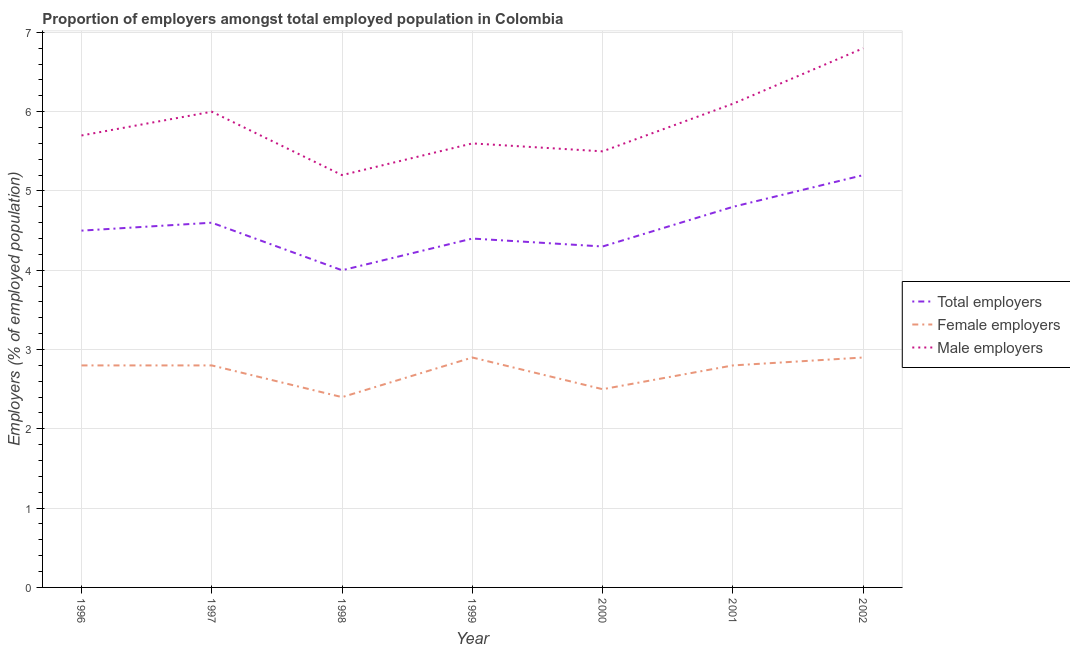Does the line corresponding to percentage of male employers intersect with the line corresponding to percentage of female employers?
Offer a terse response. No. What is the percentage of total employers in 1997?
Keep it short and to the point. 4.6. Across all years, what is the maximum percentage of total employers?
Keep it short and to the point. 5.2. In which year was the percentage of total employers minimum?
Keep it short and to the point. 1998. What is the total percentage of total employers in the graph?
Your answer should be very brief. 31.8. What is the difference between the percentage of total employers in 2000 and that in 2001?
Your response must be concise. -0.5. What is the difference between the percentage of female employers in 2001 and the percentage of male employers in 1996?
Your answer should be compact. -2.9. What is the average percentage of male employers per year?
Your response must be concise. 5.84. In the year 1997, what is the difference between the percentage of male employers and percentage of female employers?
Provide a succinct answer. 3.2. What is the ratio of the percentage of total employers in 1998 to that in 2001?
Ensure brevity in your answer.  0.83. Is the percentage of total employers in 1997 less than that in 2002?
Provide a short and direct response. Yes. What is the difference between the highest and the second highest percentage of female employers?
Offer a very short reply. 0. What is the difference between the highest and the lowest percentage of male employers?
Offer a very short reply. 1.6. In how many years, is the percentage of female employers greater than the average percentage of female employers taken over all years?
Make the answer very short. 5. Is the percentage of female employers strictly greater than the percentage of male employers over the years?
Provide a succinct answer. No. Is the percentage of male employers strictly less than the percentage of female employers over the years?
Your answer should be compact. No. How many years are there in the graph?
Offer a terse response. 7. Are the values on the major ticks of Y-axis written in scientific E-notation?
Give a very brief answer. No. Where does the legend appear in the graph?
Your response must be concise. Center right. How are the legend labels stacked?
Provide a short and direct response. Vertical. What is the title of the graph?
Keep it short and to the point. Proportion of employers amongst total employed population in Colombia. Does "Natural gas sources" appear as one of the legend labels in the graph?
Provide a succinct answer. No. What is the label or title of the X-axis?
Make the answer very short. Year. What is the label or title of the Y-axis?
Offer a very short reply. Employers (% of employed population). What is the Employers (% of employed population) of Female employers in 1996?
Offer a very short reply. 2.8. What is the Employers (% of employed population) of Male employers in 1996?
Your answer should be very brief. 5.7. What is the Employers (% of employed population) in Total employers in 1997?
Make the answer very short. 4.6. What is the Employers (% of employed population) in Female employers in 1997?
Provide a short and direct response. 2.8. What is the Employers (% of employed population) of Male employers in 1997?
Give a very brief answer. 6. What is the Employers (% of employed population) of Total employers in 1998?
Your answer should be compact. 4. What is the Employers (% of employed population) of Female employers in 1998?
Your response must be concise. 2.4. What is the Employers (% of employed population) of Male employers in 1998?
Provide a succinct answer. 5.2. What is the Employers (% of employed population) in Total employers in 1999?
Your response must be concise. 4.4. What is the Employers (% of employed population) of Female employers in 1999?
Offer a very short reply. 2.9. What is the Employers (% of employed population) of Male employers in 1999?
Give a very brief answer. 5.6. What is the Employers (% of employed population) in Total employers in 2000?
Provide a succinct answer. 4.3. What is the Employers (% of employed population) in Male employers in 2000?
Provide a succinct answer. 5.5. What is the Employers (% of employed population) of Total employers in 2001?
Provide a succinct answer. 4.8. What is the Employers (% of employed population) of Female employers in 2001?
Make the answer very short. 2.8. What is the Employers (% of employed population) of Male employers in 2001?
Give a very brief answer. 6.1. What is the Employers (% of employed population) in Total employers in 2002?
Provide a succinct answer. 5.2. What is the Employers (% of employed population) in Female employers in 2002?
Your answer should be compact. 2.9. What is the Employers (% of employed population) in Male employers in 2002?
Your answer should be compact. 6.8. Across all years, what is the maximum Employers (% of employed population) in Total employers?
Your answer should be very brief. 5.2. Across all years, what is the maximum Employers (% of employed population) of Female employers?
Keep it short and to the point. 2.9. Across all years, what is the maximum Employers (% of employed population) of Male employers?
Your answer should be very brief. 6.8. Across all years, what is the minimum Employers (% of employed population) of Total employers?
Offer a terse response. 4. Across all years, what is the minimum Employers (% of employed population) in Female employers?
Your response must be concise. 2.4. Across all years, what is the minimum Employers (% of employed population) of Male employers?
Your response must be concise. 5.2. What is the total Employers (% of employed population) in Total employers in the graph?
Offer a terse response. 31.8. What is the total Employers (% of employed population) in Male employers in the graph?
Give a very brief answer. 40.9. What is the difference between the Employers (% of employed population) of Male employers in 1996 and that in 1997?
Keep it short and to the point. -0.3. What is the difference between the Employers (% of employed population) of Female employers in 1996 and that in 1998?
Your response must be concise. 0.4. What is the difference between the Employers (% of employed population) of Male employers in 1996 and that in 1998?
Your answer should be very brief. 0.5. What is the difference between the Employers (% of employed population) in Total employers in 1996 and that in 1999?
Ensure brevity in your answer.  0.1. What is the difference between the Employers (% of employed population) in Male employers in 1996 and that in 1999?
Provide a short and direct response. 0.1. What is the difference between the Employers (% of employed population) of Female employers in 1996 and that in 2001?
Your answer should be very brief. 0. What is the difference between the Employers (% of employed population) in Male employers in 1996 and that in 2002?
Give a very brief answer. -1.1. What is the difference between the Employers (% of employed population) of Total employers in 1997 and that in 1998?
Your answer should be very brief. 0.6. What is the difference between the Employers (% of employed population) of Female employers in 1997 and that in 1998?
Keep it short and to the point. 0.4. What is the difference between the Employers (% of employed population) of Male employers in 1997 and that in 1998?
Your answer should be very brief. 0.8. What is the difference between the Employers (% of employed population) of Total employers in 1997 and that in 2000?
Give a very brief answer. 0.3. What is the difference between the Employers (% of employed population) in Female employers in 1997 and that in 2000?
Give a very brief answer. 0.3. What is the difference between the Employers (% of employed population) of Male employers in 1997 and that in 2000?
Your answer should be compact. 0.5. What is the difference between the Employers (% of employed population) of Female employers in 1998 and that in 1999?
Give a very brief answer. -0.5. What is the difference between the Employers (% of employed population) of Male employers in 1998 and that in 2000?
Provide a short and direct response. -0.3. What is the difference between the Employers (% of employed population) in Male employers in 1998 and that in 2001?
Your answer should be compact. -0.9. What is the difference between the Employers (% of employed population) of Total employers in 1998 and that in 2002?
Provide a short and direct response. -1.2. What is the difference between the Employers (% of employed population) in Male employers in 1999 and that in 2000?
Keep it short and to the point. 0.1. What is the difference between the Employers (% of employed population) of Female employers in 1999 and that in 2001?
Offer a very short reply. 0.1. What is the difference between the Employers (% of employed population) of Total employers in 2000 and that in 2002?
Offer a very short reply. -0.9. What is the difference between the Employers (% of employed population) in Female employers in 2000 and that in 2002?
Keep it short and to the point. -0.4. What is the difference between the Employers (% of employed population) in Total employers in 1996 and the Employers (% of employed population) in Female employers in 1997?
Provide a short and direct response. 1.7. What is the difference between the Employers (% of employed population) in Female employers in 1996 and the Employers (% of employed population) in Male employers in 1997?
Provide a succinct answer. -3.2. What is the difference between the Employers (% of employed population) of Total employers in 1996 and the Employers (% of employed population) of Female employers in 1998?
Your answer should be compact. 2.1. What is the difference between the Employers (% of employed population) of Total employers in 1996 and the Employers (% of employed population) of Female employers in 1999?
Give a very brief answer. 1.6. What is the difference between the Employers (% of employed population) in Total employers in 1996 and the Employers (% of employed population) in Female employers in 2000?
Provide a short and direct response. 2. What is the difference between the Employers (% of employed population) of Female employers in 1996 and the Employers (% of employed population) of Male employers in 2000?
Offer a terse response. -2.7. What is the difference between the Employers (% of employed population) in Total employers in 1996 and the Employers (% of employed population) in Male employers in 2001?
Provide a short and direct response. -1.6. What is the difference between the Employers (% of employed population) in Total employers in 1997 and the Employers (% of employed population) in Female employers in 1998?
Provide a succinct answer. 2.2. What is the difference between the Employers (% of employed population) in Total employers in 1997 and the Employers (% of employed population) in Male employers in 1998?
Keep it short and to the point. -0.6. What is the difference between the Employers (% of employed population) of Female employers in 1997 and the Employers (% of employed population) of Male employers in 1998?
Your answer should be very brief. -2.4. What is the difference between the Employers (% of employed population) of Total employers in 1997 and the Employers (% of employed population) of Female employers in 1999?
Keep it short and to the point. 1.7. What is the difference between the Employers (% of employed population) in Female employers in 1997 and the Employers (% of employed population) in Male employers in 2000?
Offer a very short reply. -2.7. What is the difference between the Employers (% of employed population) of Total employers in 1997 and the Employers (% of employed population) of Female employers in 2002?
Make the answer very short. 1.7. What is the difference between the Employers (% of employed population) in Female employers in 1997 and the Employers (% of employed population) in Male employers in 2002?
Give a very brief answer. -4. What is the difference between the Employers (% of employed population) in Total employers in 1998 and the Employers (% of employed population) in Female employers in 2000?
Provide a short and direct response. 1.5. What is the difference between the Employers (% of employed population) of Total employers in 1998 and the Employers (% of employed population) of Male employers in 2000?
Provide a short and direct response. -1.5. What is the difference between the Employers (% of employed population) of Female employers in 1998 and the Employers (% of employed population) of Male employers in 2000?
Offer a very short reply. -3.1. What is the difference between the Employers (% of employed population) of Total employers in 1998 and the Employers (% of employed population) of Female employers in 2001?
Offer a very short reply. 1.2. What is the difference between the Employers (% of employed population) of Total employers in 1998 and the Employers (% of employed population) of Male employers in 2001?
Offer a terse response. -2.1. What is the difference between the Employers (% of employed population) of Female employers in 1998 and the Employers (% of employed population) of Male employers in 2001?
Provide a short and direct response. -3.7. What is the difference between the Employers (% of employed population) of Total employers in 1998 and the Employers (% of employed population) of Female employers in 2002?
Make the answer very short. 1.1. What is the difference between the Employers (% of employed population) in Total employers in 1998 and the Employers (% of employed population) in Male employers in 2002?
Offer a terse response. -2.8. What is the difference between the Employers (% of employed population) in Female employers in 1998 and the Employers (% of employed population) in Male employers in 2002?
Provide a succinct answer. -4.4. What is the difference between the Employers (% of employed population) in Total employers in 1999 and the Employers (% of employed population) in Male employers in 2000?
Your answer should be compact. -1.1. What is the difference between the Employers (% of employed population) of Female employers in 1999 and the Employers (% of employed population) of Male employers in 2000?
Your response must be concise. -2.6. What is the difference between the Employers (% of employed population) of Total employers in 1999 and the Employers (% of employed population) of Male employers in 2001?
Ensure brevity in your answer.  -1.7. What is the difference between the Employers (% of employed population) in Total employers in 1999 and the Employers (% of employed population) in Female employers in 2002?
Your answer should be very brief. 1.5. What is the difference between the Employers (% of employed population) in Total employers in 1999 and the Employers (% of employed population) in Male employers in 2002?
Give a very brief answer. -2.4. What is the difference between the Employers (% of employed population) in Total employers in 2000 and the Employers (% of employed population) in Female employers in 2001?
Your answer should be compact. 1.5. What is the difference between the Employers (% of employed population) of Total employers in 2000 and the Employers (% of employed population) of Male employers in 2001?
Your answer should be very brief. -1.8. What is the difference between the Employers (% of employed population) in Total employers in 2000 and the Employers (% of employed population) in Female employers in 2002?
Your answer should be compact. 1.4. What is the difference between the Employers (% of employed population) in Female employers in 2000 and the Employers (% of employed population) in Male employers in 2002?
Give a very brief answer. -4.3. What is the difference between the Employers (% of employed population) in Female employers in 2001 and the Employers (% of employed population) in Male employers in 2002?
Make the answer very short. -4. What is the average Employers (% of employed population) of Total employers per year?
Make the answer very short. 4.54. What is the average Employers (% of employed population) of Female employers per year?
Offer a terse response. 2.73. What is the average Employers (% of employed population) of Male employers per year?
Your response must be concise. 5.84. In the year 1996, what is the difference between the Employers (% of employed population) in Total employers and Employers (% of employed population) in Female employers?
Ensure brevity in your answer.  1.7. In the year 1996, what is the difference between the Employers (% of employed population) in Total employers and Employers (% of employed population) in Male employers?
Your response must be concise. -1.2. In the year 1997, what is the difference between the Employers (% of employed population) of Total employers and Employers (% of employed population) of Female employers?
Your answer should be very brief. 1.8. In the year 1998, what is the difference between the Employers (% of employed population) of Total employers and Employers (% of employed population) of Male employers?
Offer a very short reply. -1.2. In the year 1998, what is the difference between the Employers (% of employed population) in Female employers and Employers (% of employed population) in Male employers?
Your response must be concise. -2.8. In the year 2000, what is the difference between the Employers (% of employed population) of Total employers and Employers (% of employed population) of Female employers?
Keep it short and to the point. 1.8. In the year 2000, what is the difference between the Employers (% of employed population) in Total employers and Employers (% of employed population) in Male employers?
Make the answer very short. -1.2. In the year 2001, what is the difference between the Employers (% of employed population) in Total employers and Employers (% of employed population) in Male employers?
Ensure brevity in your answer.  -1.3. In the year 2001, what is the difference between the Employers (% of employed population) of Female employers and Employers (% of employed population) of Male employers?
Your response must be concise. -3.3. In the year 2002, what is the difference between the Employers (% of employed population) of Total employers and Employers (% of employed population) of Female employers?
Provide a succinct answer. 2.3. In the year 2002, what is the difference between the Employers (% of employed population) in Total employers and Employers (% of employed population) in Male employers?
Provide a succinct answer. -1.6. In the year 2002, what is the difference between the Employers (% of employed population) of Female employers and Employers (% of employed population) of Male employers?
Offer a very short reply. -3.9. What is the ratio of the Employers (% of employed population) in Total employers in 1996 to that in 1997?
Offer a very short reply. 0.98. What is the ratio of the Employers (% of employed population) of Female employers in 1996 to that in 1997?
Make the answer very short. 1. What is the ratio of the Employers (% of employed population) of Total employers in 1996 to that in 1998?
Your response must be concise. 1.12. What is the ratio of the Employers (% of employed population) in Female employers in 1996 to that in 1998?
Your answer should be compact. 1.17. What is the ratio of the Employers (% of employed population) of Male employers in 1996 to that in 1998?
Give a very brief answer. 1.1. What is the ratio of the Employers (% of employed population) in Total employers in 1996 to that in 1999?
Offer a very short reply. 1.02. What is the ratio of the Employers (% of employed population) in Female employers in 1996 to that in 1999?
Your answer should be very brief. 0.97. What is the ratio of the Employers (% of employed population) of Male employers in 1996 to that in 1999?
Make the answer very short. 1.02. What is the ratio of the Employers (% of employed population) in Total employers in 1996 to that in 2000?
Your response must be concise. 1.05. What is the ratio of the Employers (% of employed population) of Female employers in 1996 to that in 2000?
Ensure brevity in your answer.  1.12. What is the ratio of the Employers (% of employed population) of Male employers in 1996 to that in 2000?
Your response must be concise. 1.04. What is the ratio of the Employers (% of employed population) of Male employers in 1996 to that in 2001?
Your answer should be very brief. 0.93. What is the ratio of the Employers (% of employed population) of Total employers in 1996 to that in 2002?
Your answer should be very brief. 0.87. What is the ratio of the Employers (% of employed population) in Female employers in 1996 to that in 2002?
Your answer should be very brief. 0.97. What is the ratio of the Employers (% of employed population) in Male employers in 1996 to that in 2002?
Your answer should be very brief. 0.84. What is the ratio of the Employers (% of employed population) of Total employers in 1997 to that in 1998?
Provide a short and direct response. 1.15. What is the ratio of the Employers (% of employed population) in Male employers in 1997 to that in 1998?
Your response must be concise. 1.15. What is the ratio of the Employers (% of employed population) of Total employers in 1997 to that in 1999?
Provide a succinct answer. 1.05. What is the ratio of the Employers (% of employed population) in Female employers in 1997 to that in 1999?
Ensure brevity in your answer.  0.97. What is the ratio of the Employers (% of employed population) in Male employers in 1997 to that in 1999?
Give a very brief answer. 1.07. What is the ratio of the Employers (% of employed population) in Total employers in 1997 to that in 2000?
Give a very brief answer. 1.07. What is the ratio of the Employers (% of employed population) of Female employers in 1997 to that in 2000?
Your answer should be compact. 1.12. What is the ratio of the Employers (% of employed population) of Female employers in 1997 to that in 2001?
Give a very brief answer. 1. What is the ratio of the Employers (% of employed population) of Male employers in 1997 to that in 2001?
Keep it short and to the point. 0.98. What is the ratio of the Employers (% of employed population) of Total employers in 1997 to that in 2002?
Ensure brevity in your answer.  0.88. What is the ratio of the Employers (% of employed population) of Female employers in 1997 to that in 2002?
Your answer should be compact. 0.97. What is the ratio of the Employers (% of employed population) of Male employers in 1997 to that in 2002?
Offer a terse response. 0.88. What is the ratio of the Employers (% of employed population) in Female employers in 1998 to that in 1999?
Provide a short and direct response. 0.83. What is the ratio of the Employers (% of employed population) in Total employers in 1998 to that in 2000?
Your response must be concise. 0.93. What is the ratio of the Employers (% of employed population) of Male employers in 1998 to that in 2000?
Your answer should be very brief. 0.95. What is the ratio of the Employers (% of employed population) of Total employers in 1998 to that in 2001?
Provide a short and direct response. 0.83. What is the ratio of the Employers (% of employed population) in Female employers in 1998 to that in 2001?
Your answer should be very brief. 0.86. What is the ratio of the Employers (% of employed population) in Male employers in 1998 to that in 2001?
Keep it short and to the point. 0.85. What is the ratio of the Employers (% of employed population) of Total employers in 1998 to that in 2002?
Provide a short and direct response. 0.77. What is the ratio of the Employers (% of employed population) in Female employers in 1998 to that in 2002?
Offer a terse response. 0.83. What is the ratio of the Employers (% of employed population) in Male employers in 1998 to that in 2002?
Keep it short and to the point. 0.76. What is the ratio of the Employers (% of employed population) in Total employers in 1999 to that in 2000?
Make the answer very short. 1.02. What is the ratio of the Employers (% of employed population) in Female employers in 1999 to that in 2000?
Offer a terse response. 1.16. What is the ratio of the Employers (% of employed population) in Male employers in 1999 to that in 2000?
Offer a very short reply. 1.02. What is the ratio of the Employers (% of employed population) in Female employers in 1999 to that in 2001?
Keep it short and to the point. 1.04. What is the ratio of the Employers (% of employed population) in Male employers in 1999 to that in 2001?
Offer a terse response. 0.92. What is the ratio of the Employers (% of employed population) in Total employers in 1999 to that in 2002?
Your response must be concise. 0.85. What is the ratio of the Employers (% of employed population) in Male employers in 1999 to that in 2002?
Your response must be concise. 0.82. What is the ratio of the Employers (% of employed population) of Total employers in 2000 to that in 2001?
Your answer should be very brief. 0.9. What is the ratio of the Employers (% of employed population) of Female employers in 2000 to that in 2001?
Your answer should be compact. 0.89. What is the ratio of the Employers (% of employed population) of Male employers in 2000 to that in 2001?
Make the answer very short. 0.9. What is the ratio of the Employers (% of employed population) of Total employers in 2000 to that in 2002?
Offer a very short reply. 0.83. What is the ratio of the Employers (% of employed population) in Female employers in 2000 to that in 2002?
Your answer should be very brief. 0.86. What is the ratio of the Employers (% of employed population) of Male employers in 2000 to that in 2002?
Ensure brevity in your answer.  0.81. What is the ratio of the Employers (% of employed population) of Female employers in 2001 to that in 2002?
Ensure brevity in your answer.  0.97. What is the ratio of the Employers (% of employed population) in Male employers in 2001 to that in 2002?
Make the answer very short. 0.9. 